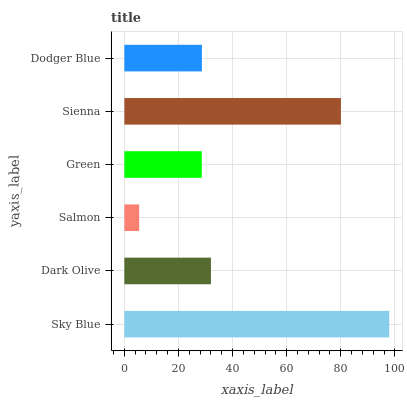Is Salmon the minimum?
Answer yes or no. Yes. Is Sky Blue the maximum?
Answer yes or no. Yes. Is Dark Olive the minimum?
Answer yes or no. No. Is Dark Olive the maximum?
Answer yes or no. No. Is Sky Blue greater than Dark Olive?
Answer yes or no. Yes. Is Dark Olive less than Sky Blue?
Answer yes or no. Yes. Is Dark Olive greater than Sky Blue?
Answer yes or no. No. Is Sky Blue less than Dark Olive?
Answer yes or no. No. Is Dark Olive the high median?
Answer yes or no. Yes. Is Dodger Blue the low median?
Answer yes or no. Yes. Is Salmon the high median?
Answer yes or no. No. Is Dark Olive the low median?
Answer yes or no. No. 